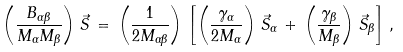<formula> <loc_0><loc_0><loc_500><loc_500>\left ( \frac { B _ { \alpha \beta } } { M _ { \alpha } M _ { \beta } } \right ) \, \vec { S } \, = \, \left ( \frac { 1 } { 2 M _ { \alpha \beta } } \right ) \, \left [ \left ( \frac { \gamma _ { \alpha } } { 2 M _ { \alpha } } \right ) \, \vec { S } _ { \alpha } \, + \, \left ( \frac { \gamma _ { \beta } } { M _ { \beta } } \right ) \, \vec { S } _ { \beta } \right ] \, ,</formula> 